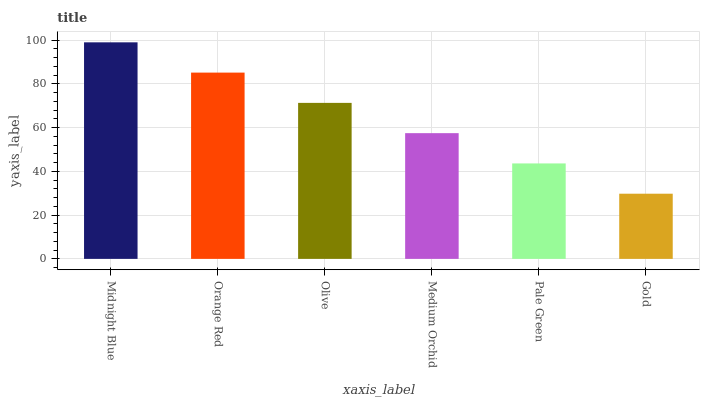Is Gold the minimum?
Answer yes or no. Yes. Is Midnight Blue the maximum?
Answer yes or no. Yes. Is Orange Red the minimum?
Answer yes or no. No. Is Orange Red the maximum?
Answer yes or no. No. Is Midnight Blue greater than Orange Red?
Answer yes or no. Yes. Is Orange Red less than Midnight Blue?
Answer yes or no. Yes. Is Orange Red greater than Midnight Blue?
Answer yes or no. No. Is Midnight Blue less than Orange Red?
Answer yes or no. No. Is Olive the high median?
Answer yes or no. Yes. Is Medium Orchid the low median?
Answer yes or no. Yes. Is Orange Red the high median?
Answer yes or no. No. Is Gold the low median?
Answer yes or no. No. 